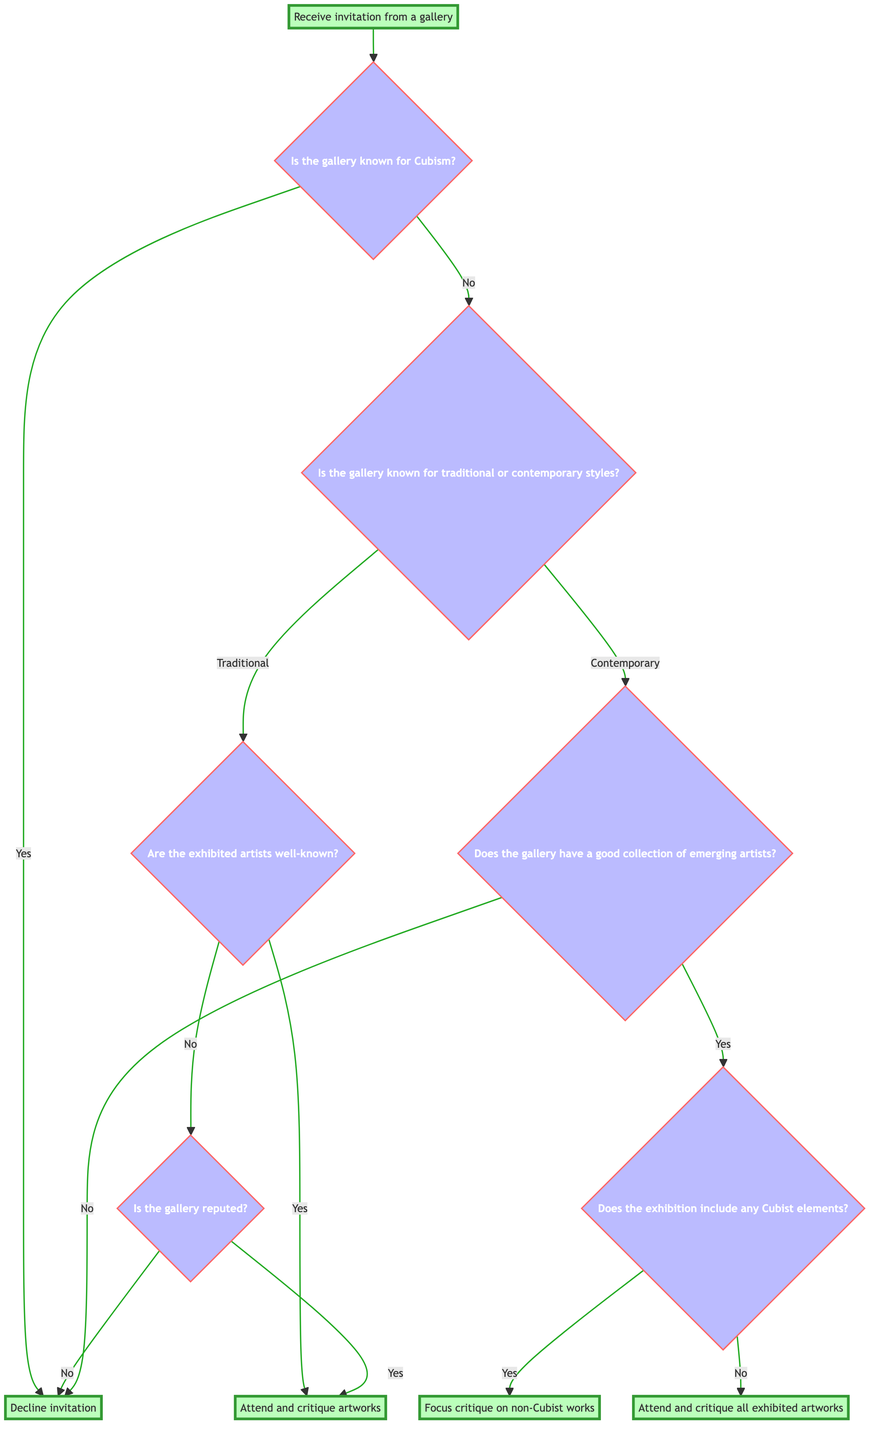What is the first step upon receiving a gallery invitation? The first step is to determine whether the gallery is known for Cubism or not. This is the initial decision point in the diagram.
Answer: Receive invitation from a gallery How many major decision points are there in this diagram? There are three major decision points: whether the gallery is known for Cubism, whether it is known for traditional or contemporary styles, and whether the exhibition includes Cubist elements.
Answer: Three What happens if the gallery is known for Cubism? If the gallery is known for Cubism, the decision is to decline the invitation, as indicated directly in the diagram.
Answer: Decline invitation If the gallery is contemporary and exhibits emerging artists, what is the next question? The next question would be whether the exhibition includes any Cubist elements, leading to further decisions based on the answer.
Answer: Does the exhibition include any Cubist elements? In a traditional gallery, what are the two follow-up questions after identifying the style? After identifying the gallery as traditional, the first follow-up question asks if the exhibited artists are well-known, and if not, whether the gallery is reputed.
Answer: Are the exhibited artists well-known? and Is the gallery reputed? What is the outcome if the artists in a traditional gallery are not well-known and the gallery is not reputed? If the artists are not well-known and the gallery is not reputed, the outcome is to decline the invitation according to the flow presented in the diagram.
Answer: Decline invitation What decision do you reach if the gallery has a good collection of emerging artists and no Cubist elements? If the gallery has a good collection of emerging artists and there are no Cubist elements, the decision is to attend and critique all exhibited artworks.
Answer: Attend and critique all exhibited artworks What are the possible actions if the gallery is contemporary but does not have a good collection of emerging artists? If the gallery is contemporary but does not have a good collection of emerging artists, the action is to decline the invitation as indicated in the diagram flow.
Answer: Decline invitation 